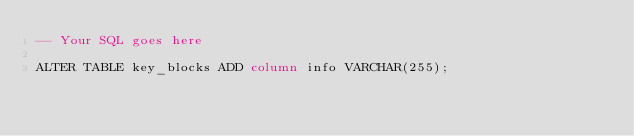<code> <loc_0><loc_0><loc_500><loc_500><_SQL_>-- Your SQL goes here

ALTER TABLE key_blocks ADD column info VARCHAR(255);
</code> 